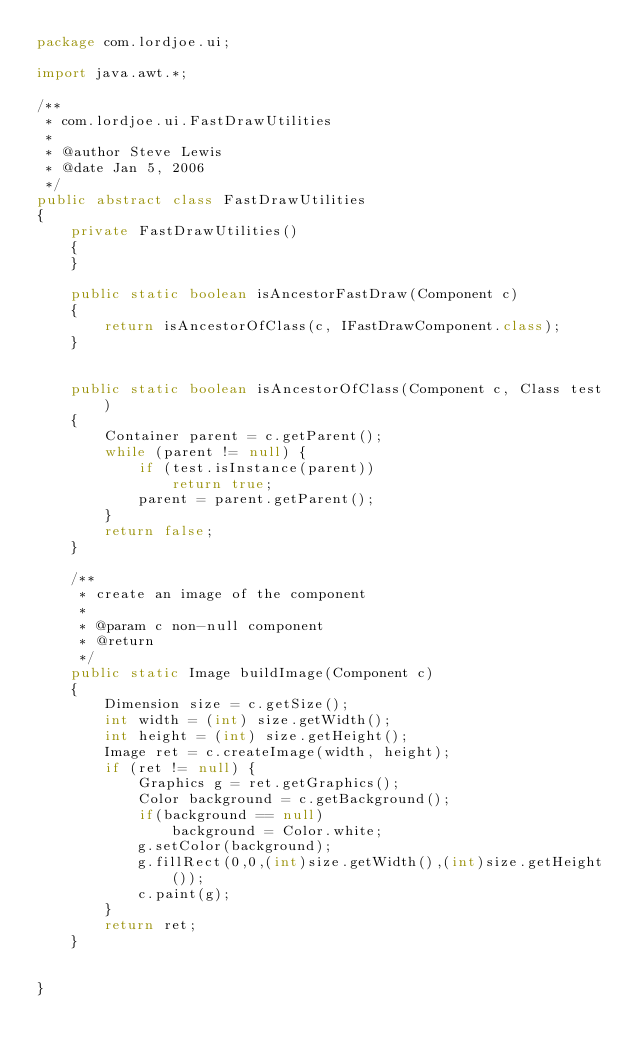Convert code to text. <code><loc_0><loc_0><loc_500><loc_500><_Java_>package com.lordjoe.ui;

import java.awt.*;

/**
 * com.lordjoe.ui.FastDrawUtilities
 *
 * @author Steve Lewis
 * @date Jan 5, 2006
 */
public abstract class FastDrawUtilities
{
    private FastDrawUtilities()
    {
    }

    public static boolean isAncestorFastDraw(Component c)
    {
        return isAncestorOfClass(c, IFastDrawComponent.class);
    }


    public static boolean isAncestorOfClass(Component c, Class test)
    {
        Container parent = c.getParent();
        while (parent != null) {
            if (test.isInstance(parent))
                return true;
            parent = parent.getParent();
        }
        return false;
    }

    /**
     * create an image of the component
     *
     * @param c non-null component
     * @return
     */
    public static Image buildImage(Component c)
    {
        Dimension size = c.getSize();
        int width = (int) size.getWidth();
        int height = (int) size.getHeight();
        Image ret = c.createImage(width, height);
        if (ret != null) {
            Graphics g = ret.getGraphics();
            Color background = c.getBackground();
            if(background == null)
                background = Color.white;
            g.setColor(background);
            g.fillRect(0,0,(int)size.getWidth(),(int)size.getHeight());
            c.paint(g);
        }
        return ret;
    }


}
</code> 